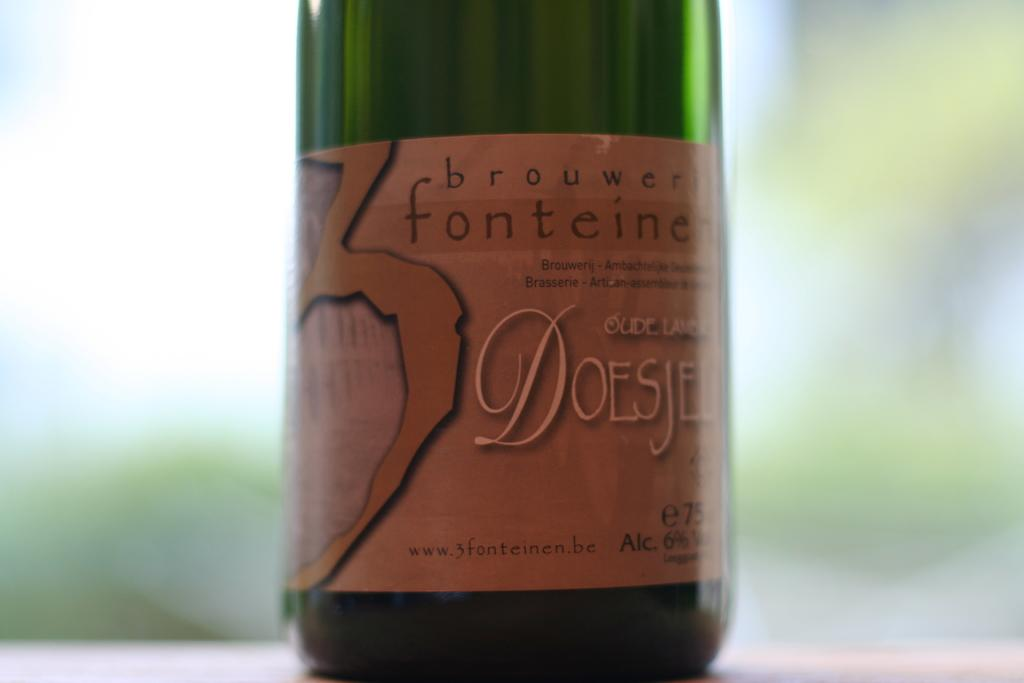<image>
Relay a brief, clear account of the picture shown. A bottle has the word brouwerij on the top of the label. 